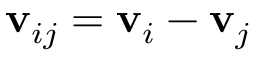Convert formula to latex. <formula><loc_0><loc_0><loc_500><loc_500>v _ { i j } = v _ { i } - v _ { j }</formula> 